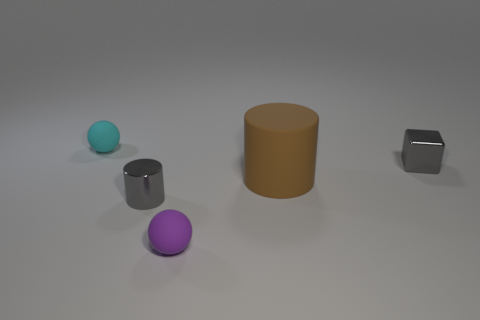Add 2 large brown objects. How many objects exist? 7 Subtract all purple spheres. How many spheres are left? 1 Subtract 0 cyan blocks. How many objects are left? 5 Subtract all balls. How many objects are left? 3 Subtract 1 spheres. How many spheres are left? 1 Subtract all red blocks. Subtract all cyan cylinders. How many blocks are left? 1 Subtract all green cylinders. How many cyan balls are left? 1 Subtract all large brown matte objects. Subtract all purple matte objects. How many objects are left? 3 Add 5 metallic things. How many metallic things are left? 7 Add 2 cyan balls. How many cyan balls exist? 3 